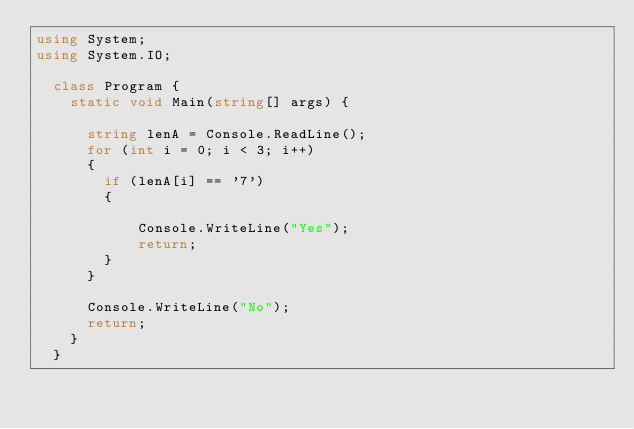<code> <loc_0><loc_0><loc_500><loc_500><_C#_>using System;
using System.IO;

  class Program {
    static void Main(string[] args) {

      string lenA = Console.ReadLine();
      for (int i = 0; i < 3; i++)
      {
        if (lenA[i] == '7')
        {
          
            Console.WriteLine("Yes");
            return;
        }
      }

      Console.WriteLine("No");
      return;
    }
  }

  
</code> 